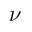Convert formula to latex. <formula><loc_0><loc_0><loc_500><loc_500>\nu</formula> 